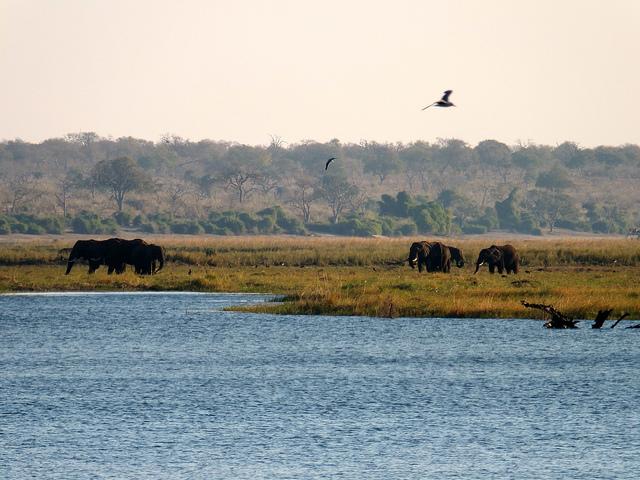Is there water?
Short answer required. Yes. Where is the flying bird?
Be succinct. In sky. Are there any baby elephants in this picture?
Quick response, please. No. 